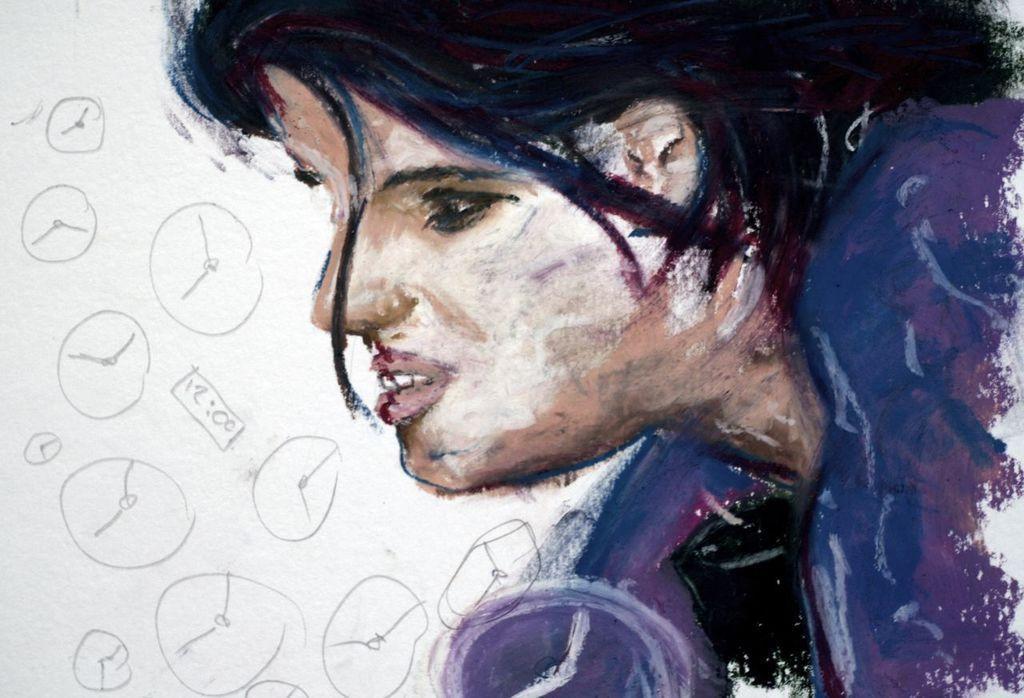Describe this image in one or two sentences. In this image I can see the painting of the person in multicolor. Background is in white color and something is written on it. 